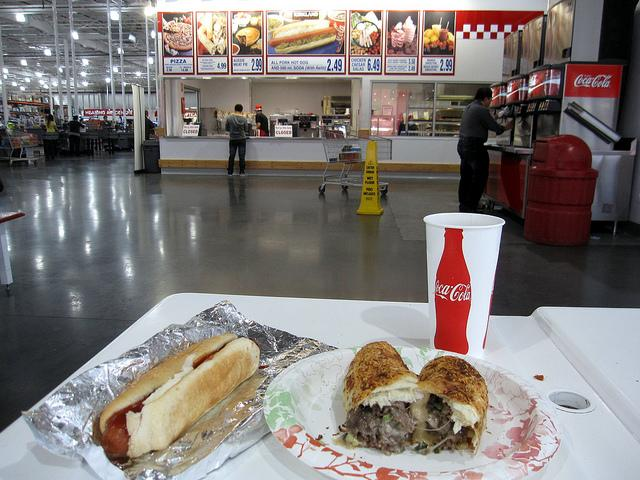Do both options have cheese on them? Please explain your reasoning. no. The hot dog only has ketchup 